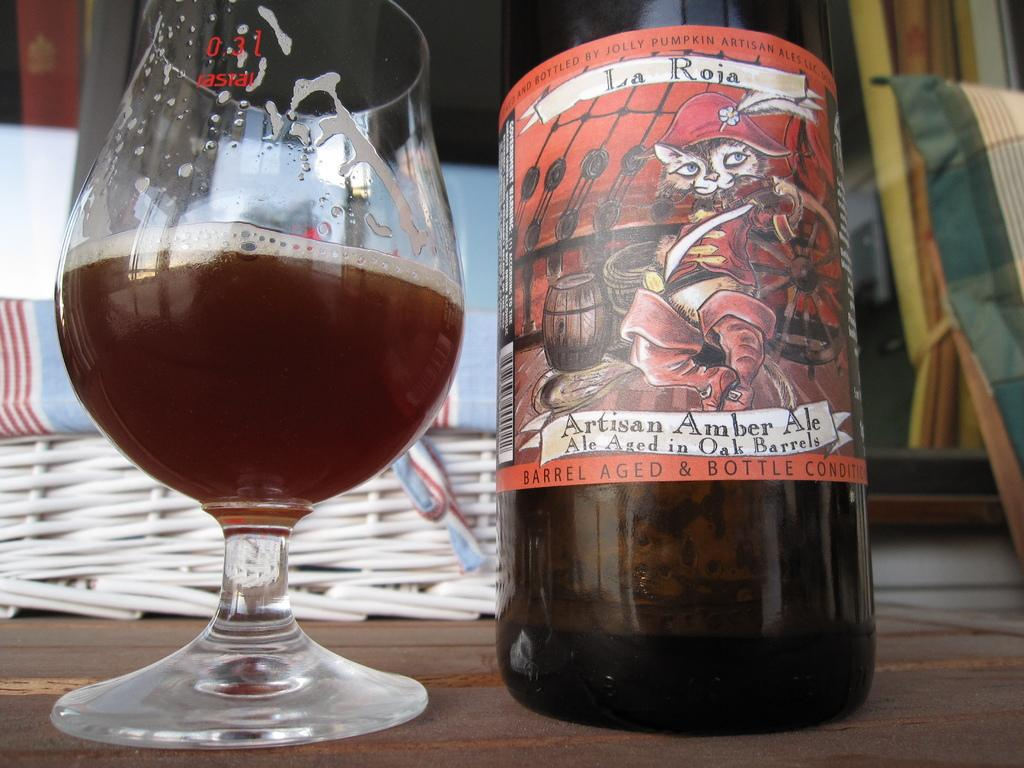What is in the glass that is visible in the image? There is a drink in the glass in the image. What else can be seen in the image besides the glass? There is a bottle in the image. What type of chicken is being discussed by the committee in the image? There is no committee or chicken present in the image; it only features a glass with a drink and a bottle. 